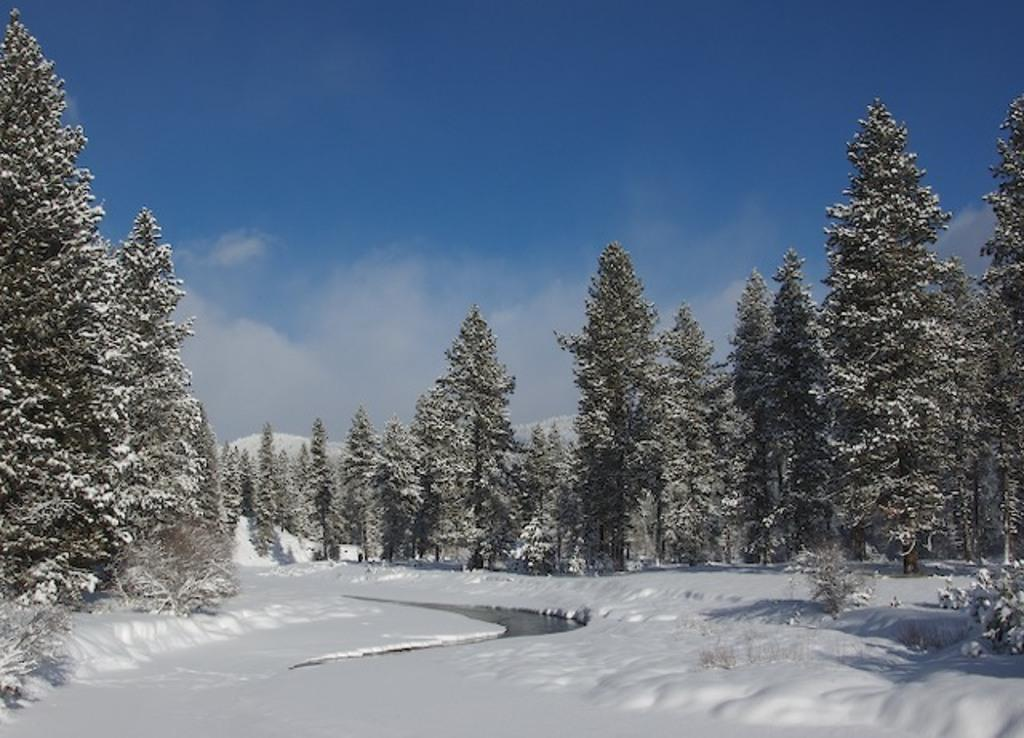What is visible at the top of the image? The sky is visible at the top of the image. What type of vegetation can be seen in the image? There are trees in the image. What is the weather like in the image? The presence of snow suggests that it is a cold or wintery scene. What natural element is visible in the image? There is water visible in the image. What type of note is attached to the star in the image? There is no star or note present in the image. What type of stew is being prepared in the image? There is no stew or cooking activity present in the image. 